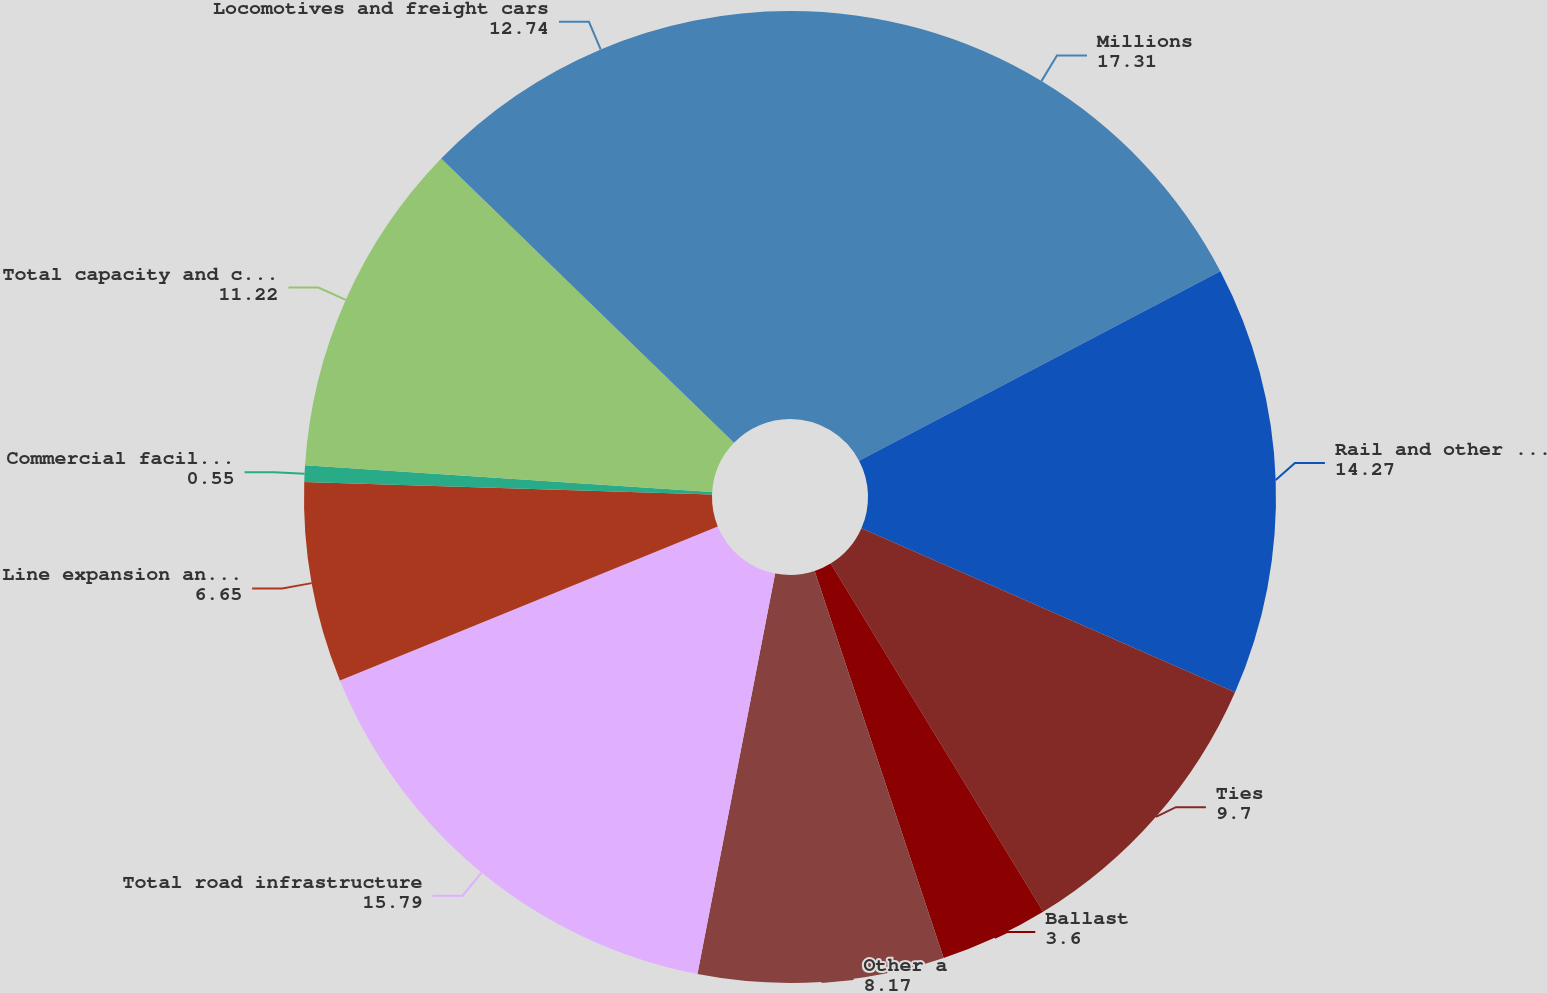Convert chart. <chart><loc_0><loc_0><loc_500><loc_500><pie_chart><fcel>Millions<fcel>Rail and other track material<fcel>Ties<fcel>Ballast<fcel>Other a<fcel>Total road infrastructure<fcel>Line expansion and other<fcel>Commercial facilities<fcel>Total capacity and commercial<fcel>Locomotives and freight cars<nl><fcel>17.31%<fcel>14.27%<fcel>9.7%<fcel>3.6%<fcel>8.17%<fcel>15.79%<fcel>6.65%<fcel>0.55%<fcel>11.22%<fcel>12.74%<nl></chart> 